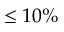Convert formula to latex. <formula><loc_0><loc_0><loc_500><loc_500>\leq 1 0 \%</formula> 